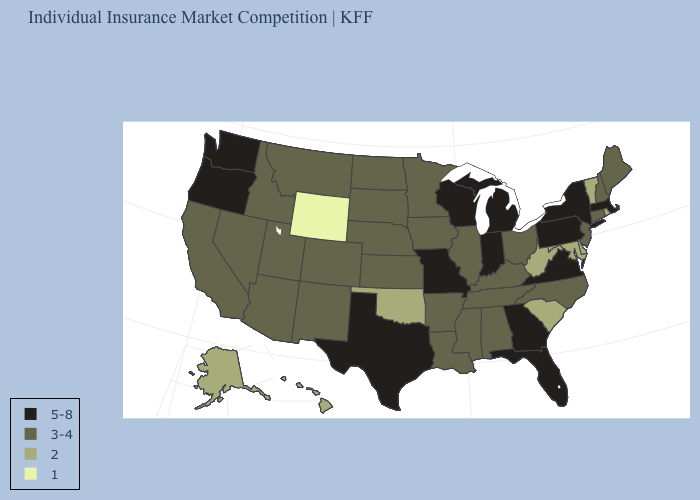Does Wyoming have the lowest value in the West?
Keep it brief. Yes. What is the value of Indiana?
Write a very short answer. 5-8. Name the states that have a value in the range 5-8?
Write a very short answer. Florida, Georgia, Indiana, Massachusetts, Michigan, Missouri, New York, Oregon, Pennsylvania, Texas, Virginia, Washington, Wisconsin. What is the value of New Hampshire?
Write a very short answer. 3-4. What is the value of Colorado?
Give a very brief answer. 3-4. Name the states that have a value in the range 3-4?
Concise answer only. Alabama, Arizona, Arkansas, California, Colorado, Connecticut, Idaho, Illinois, Iowa, Kansas, Kentucky, Louisiana, Maine, Minnesota, Mississippi, Montana, Nebraska, Nevada, New Hampshire, New Jersey, New Mexico, North Carolina, North Dakota, Ohio, South Dakota, Tennessee, Utah. What is the value of Louisiana?
Be succinct. 3-4. Name the states that have a value in the range 1?
Short answer required. Wyoming. Name the states that have a value in the range 5-8?
Quick response, please. Florida, Georgia, Indiana, Massachusetts, Michigan, Missouri, New York, Oregon, Pennsylvania, Texas, Virginia, Washington, Wisconsin. What is the highest value in the USA?
Answer briefly. 5-8. Name the states that have a value in the range 5-8?
Be succinct. Florida, Georgia, Indiana, Massachusetts, Michigan, Missouri, New York, Oregon, Pennsylvania, Texas, Virginia, Washington, Wisconsin. Among the states that border California , does Oregon have the highest value?
Keep it brief. Yes. Among the states that border Arkansas , which have the lowest value?
Write a very short answer. Oklahoma. Among the states that border New Jersey , does New York have the lowest value?
Be succinct. No. Name the states that have a value in the range 1?
Write a very short answer. Wyoming. 